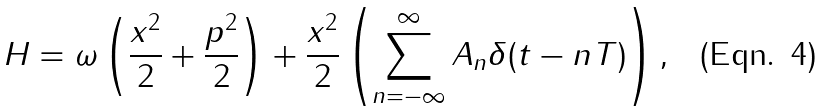Convert formula to latex. <formula><loc_0><loc_0><loc_500><loc_500>H = \omega \left ( \frac { x ^ { 2 } } { 2 } + \frac { p ^ { 2 } } { 2 } \right ) + \frac { x ^ { 2 } } { 2 } \left ( \sum _ { n = - \infty } ^ { \infty } A _ { n } \delta ( t - n T ) \right ) ,</formula> 